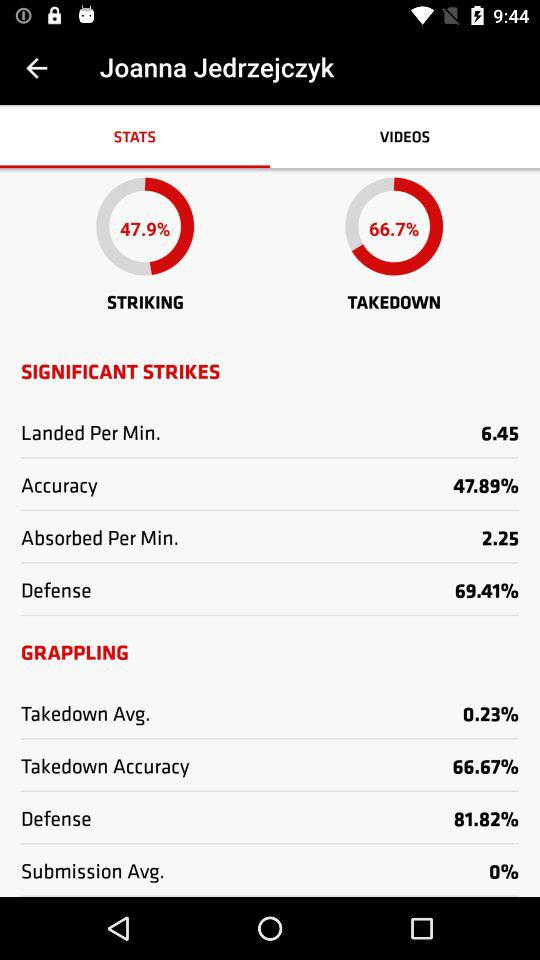How much is the takedown average? The takedown average is 0.23%. 